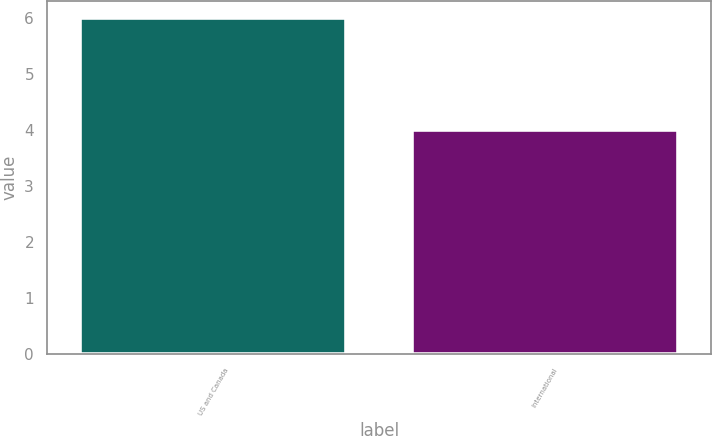<chart> <loc_0><loc_0><loc_500><loc_500><bar_chart><fcel>US and Canada<fcel>International<nl><fcel>6<fcel>4<nl></chart> 